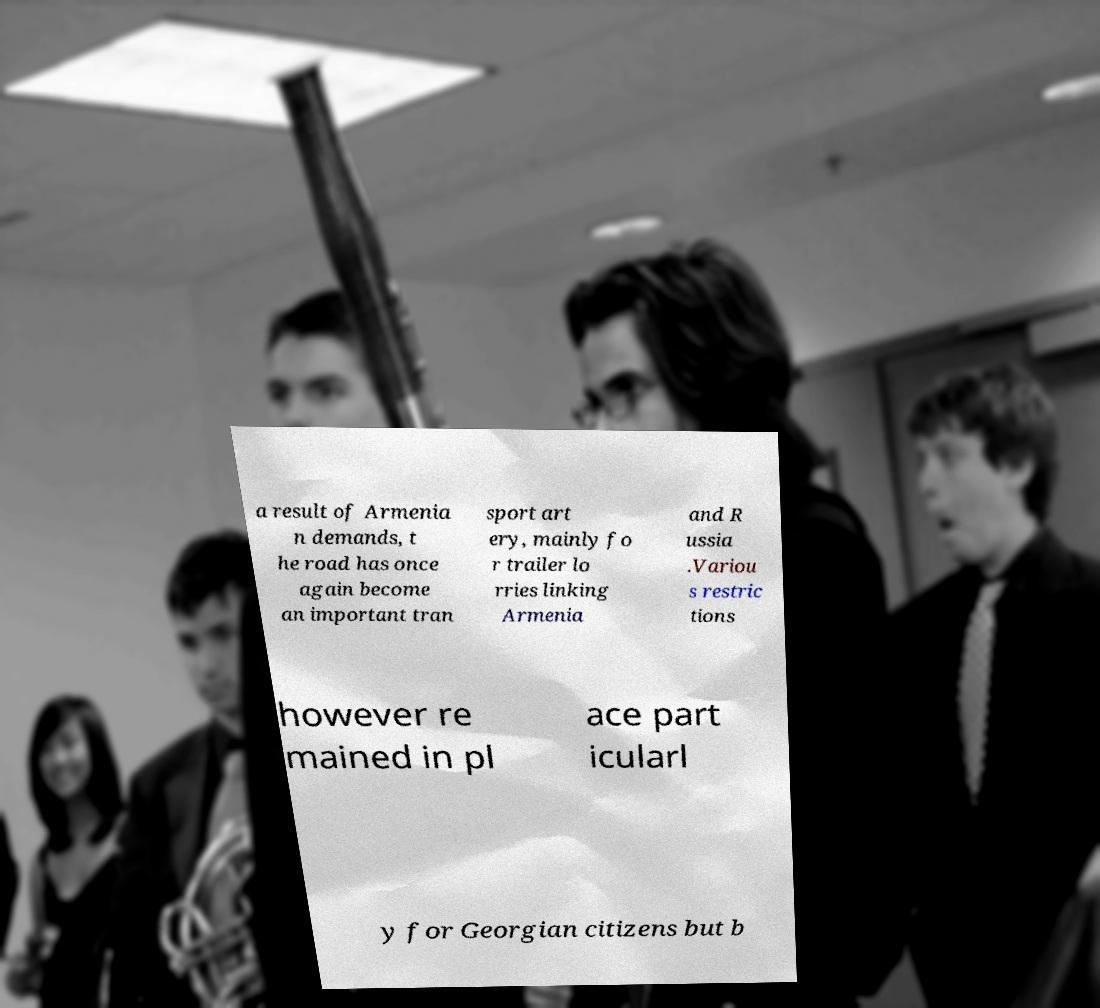Could you assist in decoding the text presented in this image and type it out clearly? a result of Armenia n demands, t he road has once again become an important tran sport art ery, mainly fo r trailer lo rries linking Armenia and R ussia .Variou s restric tions however re mained in pl ace part icularl y for Georgian citizens but b 